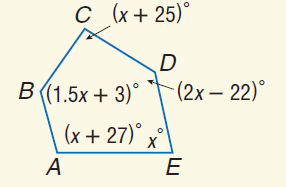Answer the mathemtical geometry problem and directly provide the correct option letter.
Question: Find m \angle E.
Choices: A: 78 B: 102 C: 103 D: 134 A 